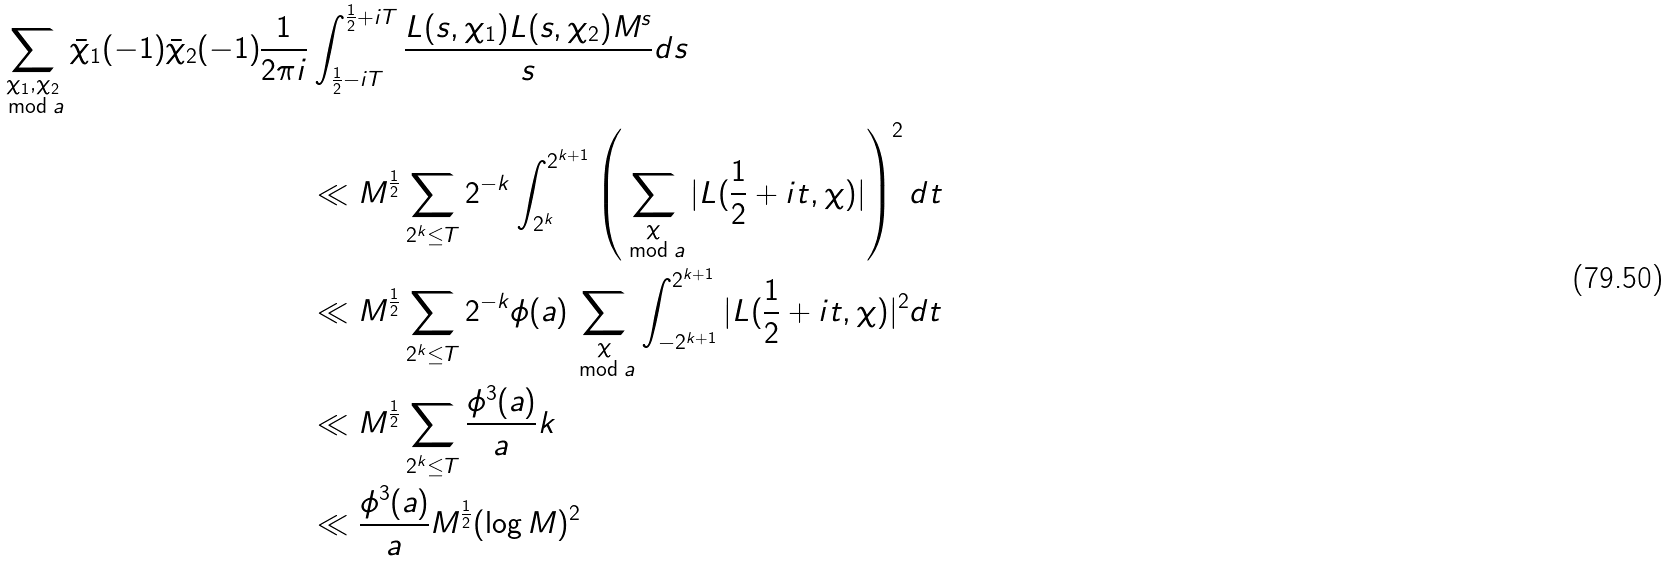Convert formula to latex. <formula><loc_0><loc_0><loc_500><loc_500>\sum _ { \substack { \chi _ { 1 } , \chi _ { 2 } \\ \bmod a } } \bar { \chi } _ { 1 } ( - 1 ) \bar { \chi } _ { 2 } ( - 1 ) \frac { 1 } { 2 \pi i } & \int _ { \frac { 1 } { 2 } - i T } ^ { \frac { 1 } { 2 } + i T } \frac { L ( s , \chi _ { 1 } ) L ( s , \chi _ { 2 } ) M ^ { s } } { s } d s \\ & \ll M ^ { \frac { 1 } { 2 } } \sum _ { 2 ^ { k } \leq T } 2 ^ { - k } \int _ { 2 ^ { k } } ^ { 2 ^ { k + 1 } } \left ( \sum _ { \substack { \chi \\ \bmod a } } | L ( \frac { 1 } { 2 } + i t , \chi ) | \right ) ^ { 2 } d t \\ & \ll M ^ { \frac { 1 } { 2 } } \sum _ { 2 ^ { k } \leq T } 2 ^ { - k } \phi ( a ) \sum _ { \substack { \chi \\ \bmod a } } \int _ { - 2 ^ { k + 1 } } ^ { 2 ^ { k + 1 } } | L ( \frac { 1 } { 2 } + i t , \chi ) | ^ { 2 } d t \\ & \ll M ^ { \frac { 1 } { 2 } } \sum _ { 2 ^ { k } \leq T } \frac { \phi ^ { 3 } ( a ) } { a } k \\ & \ll \frac { \phi ^ { 3 } ( a ) } { a } M ^ { \frac { 1 } { 2 } } ( \log M ) ^ { 2 }</formula> 